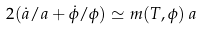<formula> <loc_0><loc_0><loc_500><loc_500>2 ( \dot { a } / a + \dot { \phi } / \phi ) \simeq m ( T , \phi ) \, a</formula> 